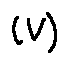<formula> <loc_0><loc_0><loc_500><loc_500>( V )</formula> 